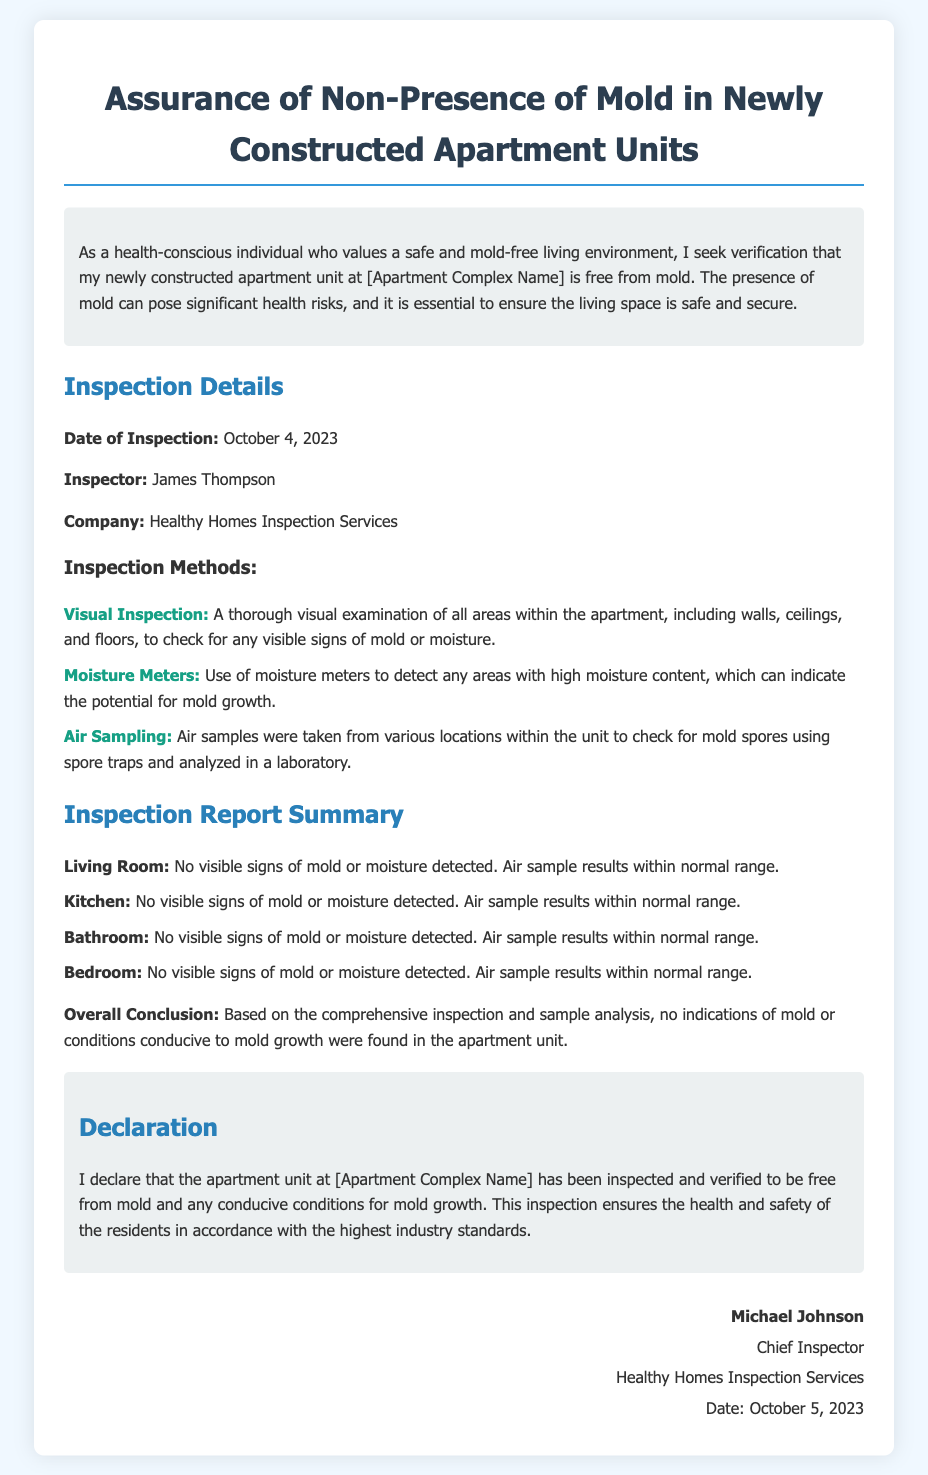What is the date of inspection? The date of inspection is specified in the document as the date when the inspection took place.
Answer: October 4, 2023 Who is the inspector? The document lists the inspector's name, which is important for accountability and verification.
Answer: James Thompson What company conducted the inspection? The company responsible for the inspection is mentioned in the document and is key information for future inquiries.
Answer: Healthy Homes Inspection Services What is the conclusion of the inspection? The conclusion summarizes the findings of the inspection, determining the status of mold presence in the apartment unit.
Answer: No indications of mold or conditions conducive to mold growth Which area is mentioned last in the inspection report summary? The last area listed in the summary provides insight into the thoroughness of the inspection across various parts of the apartment.
Answer: Bedroom What methods were used for inspection? The document specifies various methods that were used to assure a thorough inspection, which is critical for understanding the assessment process.
Answer: Visual Inspection, Moisture Meters, Air Sampling What is the date of the declaration signature? The signature date affirms when the declaration was formally completed and can provide context for the timing of the inspection.
Answer: October 5, 2023 What is the main purpose of this declaration document? This question aims to clarify the objective behind creating this specific document pertaining to mold assurance.
Answer: Assurance of Non-Presence of Mold in Newly Constructed Apartment Units 